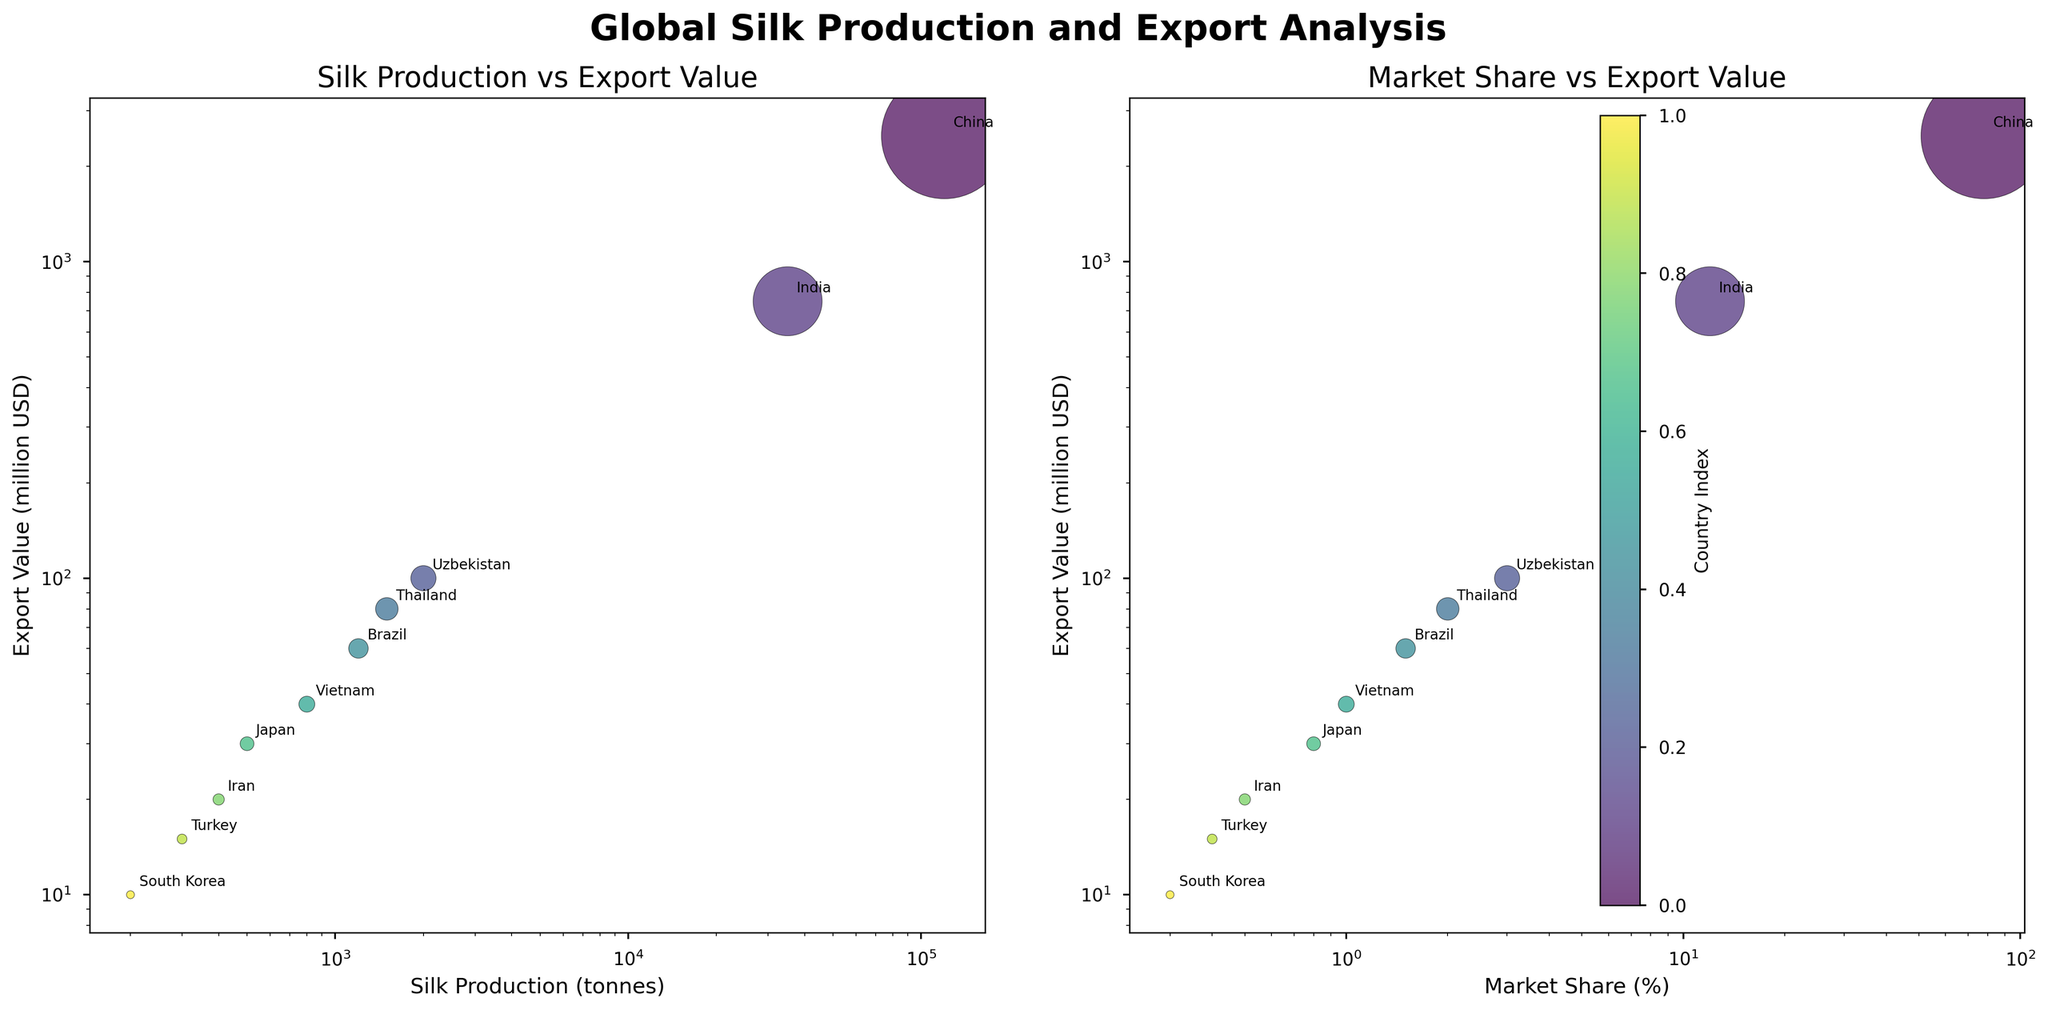How many countries are represented in the figure? The figure shows data points for each country in the dataset. By counting the individual data points, we can determine that there are ten countries.
Answer: 10 What is the range of silk production values represented in the figure? The x-axis in the first subplot represents silk production in tonnes. The lowest production value is 200 tonnes (South Korea), and the highest production value is 120000 tonnes (China). The difference between these values is 120000 - 200 = 119800 tonnes.
Answer: 119800 tonnes Which country has the largest bubble (export value) in both subplots? The bubble size represents the export value. By visually inspecting the figure, China has the largest bubbles in both subplots, indicating it has the highest export value.
Answer: China Compare the market share of Turkey and Iran. Which country has a higher market share? The second subplot shows market share on the x-axis. By comparing the position of Turkey and Iran, Turkey (0.4%) has a lower market share than Iran (0.5%).
Answer: Iran Identify the country with the smallest export value. The vertical position (y-axis) in both subplots represents export value. South Korea, at the lowest y-position in both subplots, has the smallest export value of 10 million USD.
Answer: South Korea What is the combined export value of Brazil and Vietnam? From the figure, Brazil has an export value of 60 million USD, and Vietnam has 40 million USD. Adding these gives 60 + 40 = 100 million USD.
Answer: 100 million USD How does Thailand's silk production compare to Japan's on a logarithmic scale? Observing the first subplot, Thailand's silk production is 1500 tonnes while Japan's is 500 tonnes. On a logarithmic scale, since 1500 > 500, Thailand's production is higher than Japan's.
Answer: Thailand Which country has a lower market share: Vietnam or Japan? From the second subplot, Vietnam has a market share of 1%, whereas Japan has 0.8%. Therefore, Japan has a lower market share.
Answer: Japan What is the relationship between export value and market share for India? In the second subplot, India's point lies further to the right (12% market share) and higher up (750 million USD export value) compared to most other countries, demonstrating a positive relationship between its export value and market share.
Answer: Positive relationship Assess the range of export values for countries with less than 5% market share. From the second subplot, Uzbekistan (100 million USD), Thailand (80 million USD), Brazil (60 million USD), Vietnam (40 million USD), Japan (30 million USD), Iran (20 million USD), Turkey (15 million USD), and South Korea (10 million USD) all have less than 5% market share. The range is from 10 to 100 million USD.
Answer: 10 to 100 million USD 